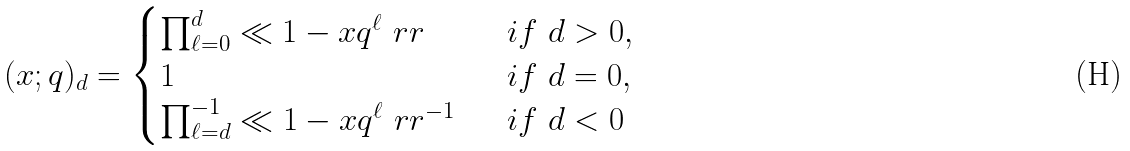<formula> <loc_0><loc_0><loc_500><loc_500>( x ; q ) _ { d } = \begin{cases} \prod _ { \ell = 0 } ^ { d } \ll 1 - x q ^ { \ell } \ r r \ \ & i f \ d > 0 , \\ 1 & i f \ d = 0 , \\ \prod _ { \ell = d } ^ { - 1 } \ll 1 - x q ^ { \ell } \ r r ^ { - 1 } \ \ & i f \ d < 0 \end{cases}</formula> 